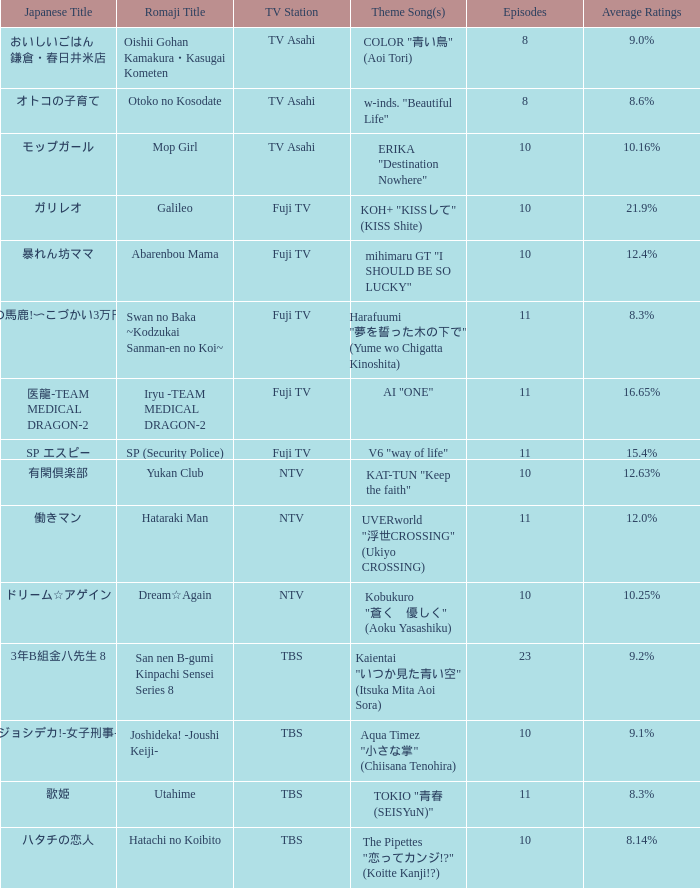What is the Theme Song of the show on Fuji TV Station with Average Ratings of 16.65%? AI "ONE". 